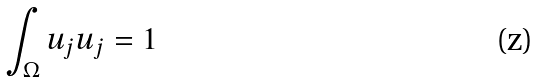<formula> <loc_0><loc_0><loc_500><loc_500>\int _ { \Omega } u _ { j } u _ { j } = 1</formula> 